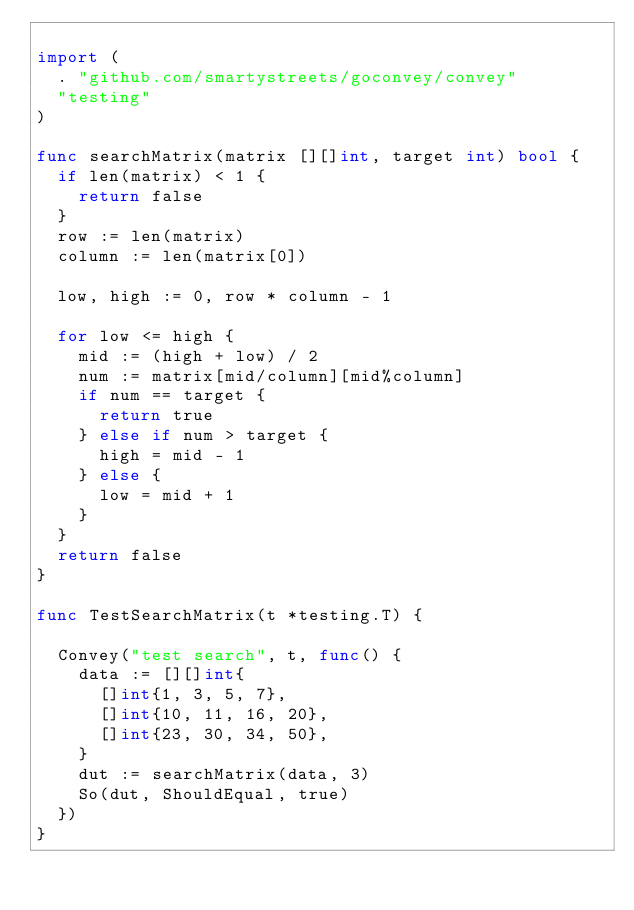<code> <loc_0><loc_0><loc_500><loc_500><_Go_>
import (
	. "github.com/smartystreets/goconvey/convey"
	"testing"
)

func searchMatrix(matrix [][]int, target int) bool {
	if len(matrix) < 1 {
		return false
	}
	row := len(matrix)
	column := len(matrix[0])

	low, high := 0, row * column - 1

	for low <= high {
		mid := (high + low) / 2
		num := matrix[mid/column][mid%column]
		if num == target {
			return true
		} else if num > target {
			high = mid - 1
		} else {
			low = mid + 1
		}
	}
	return false
}

func TestSearchMatrix(t *testing.T) {

	Convey("test search", t, func() {
		data := [][]int{
			[]int{1, 3, 5, 7},
			[]int{10, 11, 16, 20},
			[]int{23, 30, 34, 50},
		}
    dut := searchMatrix(data, 3)
		So(dut, ShouldEqual, true)
	})
}
</code> 